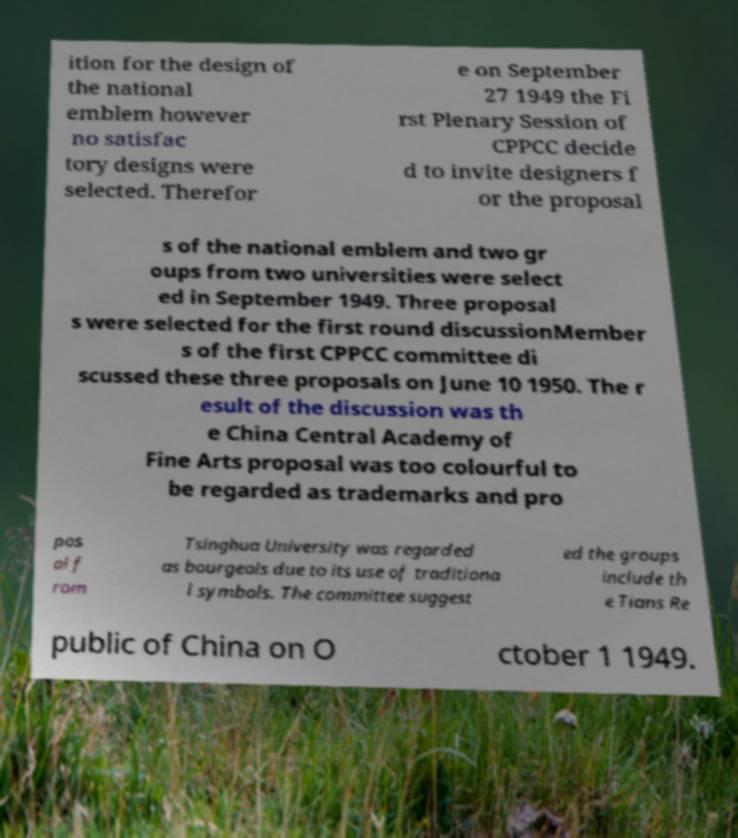Could you extract and type out the text from this image? ition for the design of the national emblem however no satisfac tory designs were selected. Therefor e on September 27 1949 the Fi rst Plenary Session of CPPCC decide d to invite designers f or the proposal s of the national emblem and two gr oups from two universities were select ed in September 1949. Three proposal s were selected for the first round discussionMember s of the first CPPCC committee di scussed these three proposals on June 10 1950. The r esult of the discussion was th e China Central Academy of Fine Arts proposal was too colourful to be regarded as trademarks and pro pos al f rom Tsinghua University was regarded as bourgeois due to its use of traditiona l symbols. The committee suggest ed the groups include th e Tians Re public of China on O ctober 1 1949. 